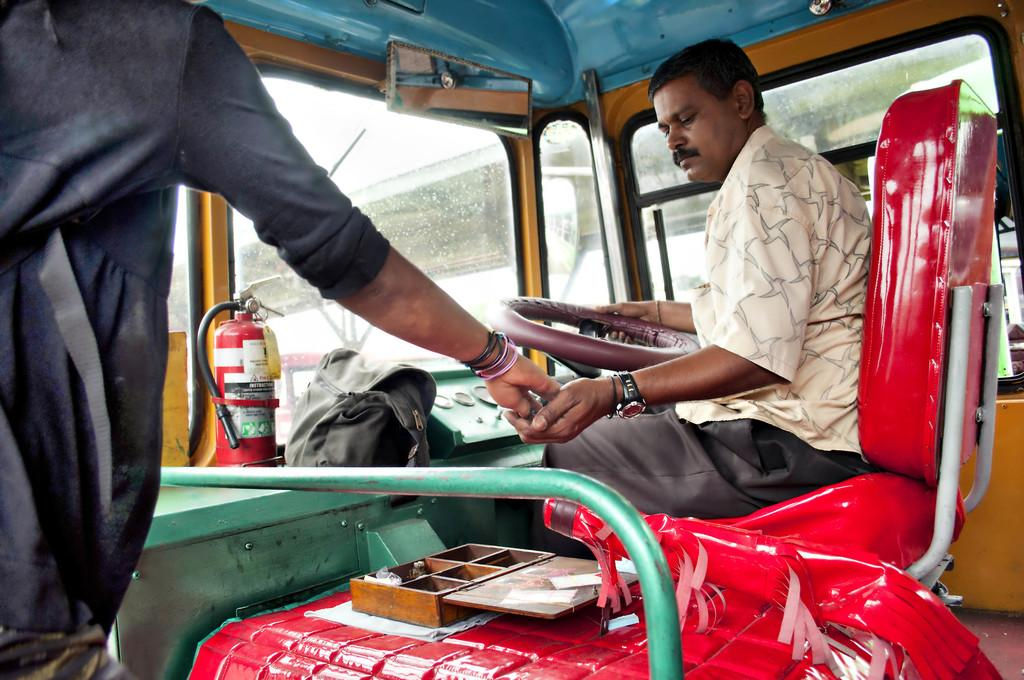What is the main subject of the image? There is a vehicle in the image. Who or what is inside the vehicle? Two persons are sitting in the vehicle. What safety equipment is present in the vehicle? There is a fire extinguisher in the vehicle. What else can be seen inside the vehicle? There is a bag in the vehicle. What can be seen through the windshield of the vehicle? Another vehicle is visible through the windshield. What type of nose can be seen on the cat in the image? There are no cats present in the image, so there is no nose to describe. What color is the lipstick on the person's lip in the image? There is no mention of lipstick or lips in the image, so we cannot determine the color of any lipstick. 